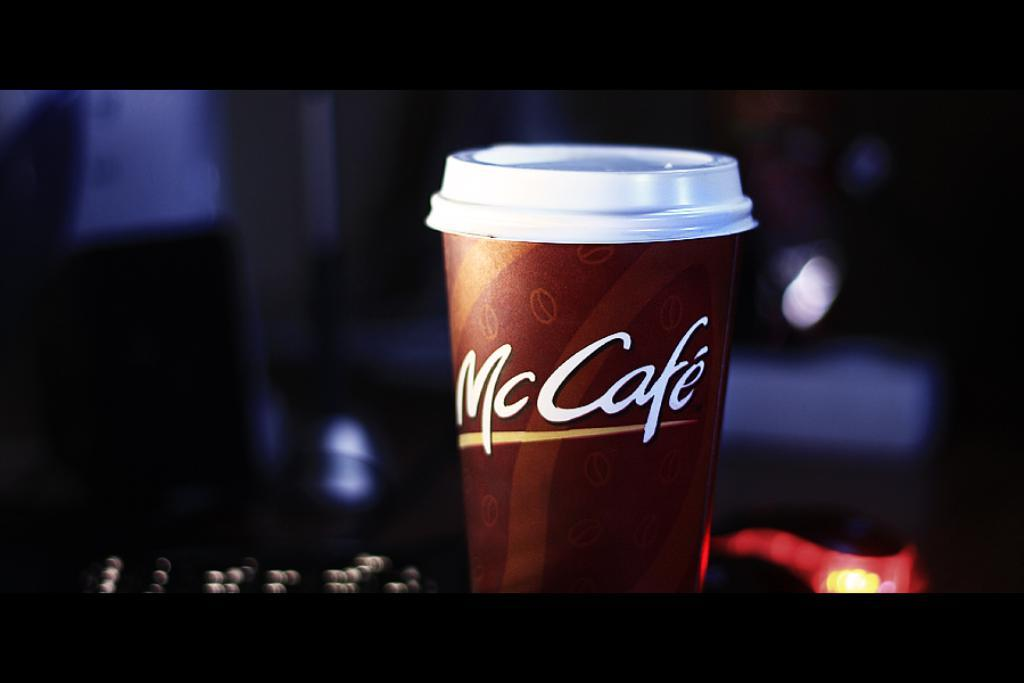Provide a one-sentence caption for the provided image. An ad or picture of a mccafe coffee with the white lid on top. 